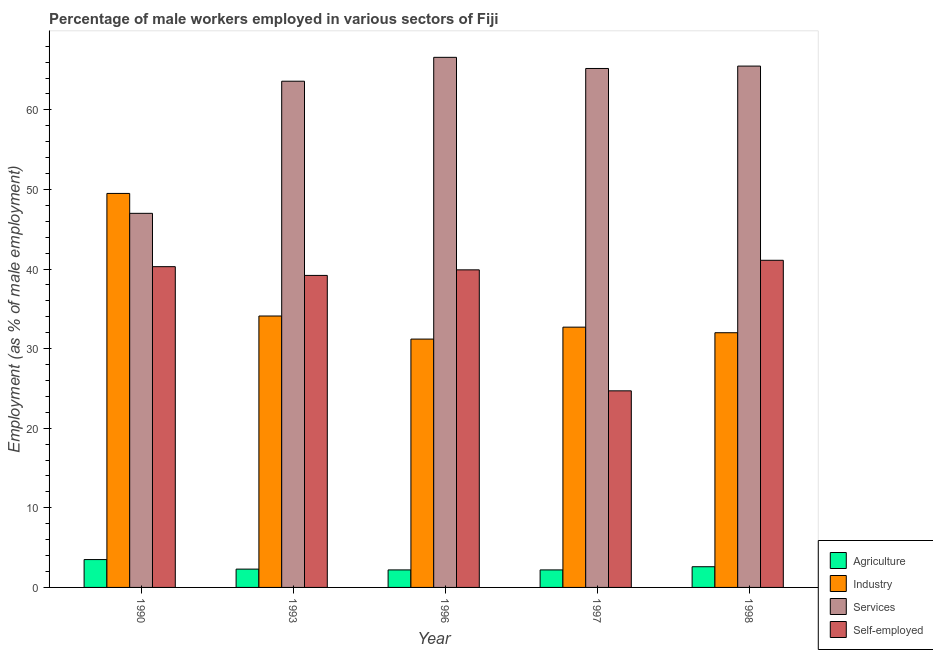Are the number of bars on each tick of the X-axis equal?
Your answer should be compact. Yes. How many bars are there on the 4th tick from the right?
Provide a short and direct response. 4. What is the label of the 5th group of bars from the left?
Your answer should be very brief. 1998. In how many cases, is the number of bars for a given year not equal to the number of legend labels?
Your response must be concise. 0. What is the percentage of male workers in industry in 1998?
Provide a short and direct response. 32. Across all years, what is the maximum percentage of male workers in services?
Make the answer very short. 66.6. Across all years, what is the minimum percentage of self employed male workers?
Your answer should be compact. 24.7. In which year was the percentage of self employed male workers maximum?
Make the answer very short. 1998. In which year was the percentage of male workers in services minimum?
Ensure brevity in your answer.  1990. What is the total percentage of male workers in services in the graph?
Your response must be concise. 307.9. What is the difference between the percentage of male workers in agriculture in 1993 and that in 1996?
Keep it short and to the point. 0.1. What is the difference between the percentage of self employed male workers in 1997 and the percentage of male workers in industry in 1990?
Provide a succinct answer. -15.6. What is the average percentage of male workers in services per year?
Give a very brief answer. 61.58. In the year 1997, what is the difference between the percentage of male workers in industry and percentage of male workers in agriculture?
Offer a terse response. 0. What is the ratio of the percentage of male workers in services in 1997 to that in 1998?
Your answer should be compact. 1. Is the difference between the percentage of male workers in industry in 1990 and 1998 greater than the difference between the percentage of male workers in services in 1990 and 1998?
Provide a succinct answer. No. What is the difference between the highest and the second highest percentage of self employed male workers?
Give a very brief answer. 0.8. What is the difference between the highest and the lowest percentage of male workers in agriculture?
Ensure brevity in your answer.  1.3. Is the sum of the percentage of male workers in agriculture in 1990 and 1997 greater than the maximum percentage of male workers in services across all years?
Provide a succinct answer. Yes. Is it the case that in every year, the sum of the percentage of male workers in agriculture and percentage of self employed male workers is greater than the sum of percentage of male workers in services and percentage of male workers in industry?
Keep it short and to the point. No. What does the 1st bar from the left in 1998 represents?
Give a very brief answer. Agriculture. What does the 3rd bar from the right in 1993 represents?
Offer a very short reply. Industry. Is it the case that in every year, the sum of the percentage of male workers in agriculture and percentage of male workers in industry is greater than the percentage of male workers in services?
Your answer should be very brief. No. How many bars are there?
Ensure brevity in your answer.  20. Are all the bars in the graph horizontal?
Your answer should be compact. No. Does the graph contain any zero values?
Offer a very short reply. No. Does the graph contain grids?
Offer a terse response. No. How many legend labels are there?
Offer a very short reply. 4. How are the legend labels stacked?
Keep it short and to the point. Vertical. What is the title of the graph?
Offer a very short reply. Percentage of male workers employed in various sectors of Fiji. What is the label or title of the Y-axis?
Offer a terse response. Employment (as % of male employment). What is the Employment (as % of male employment) of Agriculture in 1990?
Your answer should be compact. 3.5. What is the Employment (as % of male employment) of Industry in 1990?
Your answer should be very brief. 49.5. What is the Employment (as % of male employment) in Services in 1990?
Your answer should be compact. 47. What is the Employment (as % of male employment) of Self-employed in 1990?
Keep it short and to the point. 40.3. What is the Employment (as % of male employment) in Agriculture in 1993?
Offer a terse response. 2.3. What is the Employment (as % of male employment) in Industry in 1993?
Keep it short and to the point. 34.1. What is the Employment (as % of male employment) in Services in 1993?
Your answer should be very brief. 63.6. What is the Employment (as % of male employment) in Self-employed in 1993?
Offer a very short reply. 39.2. What is the Employment (as % of male employment) in Agriculture in 1996?
Provide a short and direct response. 2.2. What is the Employment (as % of male employment) in Industry in 1996?
Make the answer very short. 31.2. What is the Employment (as % of male employment) of Services in 1996?
Your answer should be compact. 66.6. What is the Employment (as % of male employment) of Self-employed in 1996?
Give a very brief answer. 39.9. What is the Employment (as % of male employment) of Agriculture in 1997?
Your answer should be compact. 2.2. What is the Employment (as % of male employment) of Industry in 1997?
Your answer should be very brief. 32.7. What is the Employment (as % of male employment) of Services in 1997?
Provide a short and direct response. 65.2. What is the Employment (as % of male employment) of Self-employed in 1997?
Make the answer very short. 24.7. What is the Employment (as % of male employment) in Agriculture in 1998?
Your answer should be compact. 2.6. What is the Employment (as % of male employment) in Industry in 1998?
Make the answer very short. 32. What is the Employment (as % of male employment) of Services in 1998?
Your answer should be compact. 65.5. What is the Employment (as % of male employment) in Self-employed in 1998?
Offer a terse response. 41.1. Across all years, what is the maximum Employment (as % of male employment) in Industry?
Provide a short and direct response. 49.5. Across all years, what is the maximum Employment (as % of male employment) of Services?
Provide a succinct answer. 66.6. Across all years, what is the maximum Employment (as % of male employment) in Self-employed?
Your response must be concise. 41.1. Across all years, what is the minimum Employment (as % of male employment) in Agriculture?
Your answer should be very brief. 2.2. Across all years, what is the minimum Employment (as % of male employment) in Industry?
Your response must be concise. 31.2. Across all years, what is the minimum Employment (as % of male employment) in Services?
Keep it short and to the point. 47. Across all years, what is the minimum Employment (as % of male employment) of Self-employed?
Give a very brief answer. 24.7. What is the total Employment (as % of male employment) of Agriculture in the graph?
Your response must be concise. 12.8. What is the total Employment (as % of male employment) of Industry in the graph?
Your response must be concise. 179.5. What is the total Employment (as % of male employment) of Services in the graph?
Keep it short and to the point. 307.9. What is the total Employment (as % of male employment) of Self-employed in the graph?
Keep it short and to the point. 185.2. What is the difference between the Employment (as % of male employment) in Industry in 1990 and that in 1993?
Give a very brief answer. 15.4. What is the difference between the Employment (as % of male employment) of Services in 1990 and that in 1993?
Provide a short and direct response. -16.6. What is the difference between the Employment (as % of male employment) in Self-employed in 1990 and that in 1993?
Your answer should be very brief. 1.1. What is the difference between the Employment (as % of male employment) of Agriculture in 1990 and that in 1996?
Offer a terse response. 1.3. What is the difference between the Employment (as % of male employment) in Services in 1990 and that in 1996?
Your answer should be compact. -19.6. What is the difference between the Employment (as % of male employment) of Industry in 1990 and that in 1997?
Keep it short and to the point. 16.8. What is the difference between the Employment (as % of male employment) in Services in 1990 and that in 1997?
Ensure brevity in your answer.  -18.2. What is the difference between the Employment (as % of male employment) in Industry in 1990 and that in 1998?
Offer a very short reply. 17.5. What is the difference between the Employment (as % of male employment) in Services in 1990 and that in 1998?
Provide a succinct answer. -18.5. What is the difference between the Employment (as % of male employment) in Agriculture in 1993 and that in 1996?
Make the answer very short. 0.1. What is the difference between the Employment (as % of male employment) of Services in 1993 and that in 1996?
Offer a terse response. -3. What is the difference between the Employment (as % of male employment) in Agriculture in 1993 and that in 1997?
Give a very brief answer. 0.1. What is the difference between the Employment (as % of male employment) in Services in 1993 and that in 1997?
Your answer should be very brief. -1.6. What is the difference between the Employment (as % of male employment) in Agriculture in 1993 and that in 1998?
Make the answer very short. -0.3. What is the difference between the Employment (as % of male employment) of Industry in 1993 and that in 1998?
Offer a terse response. 2.1. What is the difference between the Employment (as % of male employment) in Agriculture in 1996 and that in 1997?
Give a very brief answer. 0. What is the difference between the Employment (as % of male employment) in Industry in 1996 and that in 1997?
Provide a short and direct response. -1.5. What is the difference between the Employment (as % of male employment) of Agriculture in 1996 and that in 1998?
Keep it short and to the point. -0.4. What is the difference between the Employment (as % of male employment) in Services in 1996 and that in 1998?
Your answer should be compact. 1.1. What is the difference between the Employment (as % of male employment) in Self-employed in 1996 and that in 1998?
Give a very brief answer. -1.2. What is the difference between the Employment (as % of male employment) of Agriculture in 1997 and that in 1998?
Provide a short and direct response. -0.4. What is the difference between the Employment (as % of male employment) in Services in 1997 and that in 1998?
Ensure brevity in your answer.  -0.3. What is the difference between the Employment (as % of male employment) of Self-employed in 1997 and that in 1998?
Your answer should be very brief. -16.4. What is the difference between the Employment (as % of male employment) of Agriculture in 1990 and the Employment (as % of male employment) of Industry in 1993?
Make the answer very short. -30.6. What is the difference between the Employment (as % of male employment) of Agriculture in 1990 and the Employment (as % of male employment) of Services in 1993?
Provide a short and direct response. -60.1. What is the difference between the Employment (as % of male employment) of Agriculture in 1990 and the Employment (as % of male employment) of Self-employed in 1993?
Your answer should be very brief. -35.7. What is the difference between the Employment (as % of male employment) of Industry in 1990 and the Employment (as % of male employment) of Services in 1993?
Provide a succinct answer. -14.1. What is the difference between the Employment (as % of male employment) in Services in 1990 and the Employment (as % of male employment) in Self-employed in 1993?
Ensure brevity in your answer.  7.8. What is the difference between the Employment (as % of male employment) of Agriculture in 1990 and the Employment (as % of male employment) of Industry in 1996?
Ensure brevity in your answer.  -27.7. What is the difference between the Employment (as % of male employment) of Agriculture in 1990 and the Employment (as % of male employment) of Services in 1996?
Give a very brief answer. -63.1. What is the difference between the Employment (as % of male employment) in Agriculture in 1990 and the Employment (as % of male employment) in Self-employed in 1996?
Your answer should be compact. -36.4. What is the difference between the Employment (as % of male employment) in Industry in 1990 and the Employment (as % of male employment) in Services in 1996?
Keep it short and to the point. -17.1. What is the difference between the Employment (as % of male employment) in Industry in 1990 and the Employment (as % of male employment) in Self-employed in 1996?
Provide a succinct answer. 9.6. What is the difference between the Employment (as % of male employment) of Agriculture in 1990 and the Employment (as % of male employment) of Industry in 1997?
Ensure brevity in your answer.  -29.2. What is the difference between the Employment (as % of male employment) of Agriculture in 1990 and the Employment (as % of male employment) of Services in 1997?
Ensure brevity in your answer.  -61.7. What is the difference between the Employment (as % of male employment) of Agriculture in 1990 and the Employment (as % of male employment) of Self-employed in 1997?
Your answer should be compact. -21.2. What is the difference between the Employment (as % of male employment) of Industry in 1990 and the Employment (as % of male employment) of Services in 1997?
Ensure brevity in your answer.  -15.7. What is the difference between the Employment (as % of male employment) in Industry in 1990 and the Employment (as % of male employment) in Self-employed in 1997?
Ensure brevity in your answer.  24.8. What is the difference between the Employment (as % of male employment) in Services in 1990 and the Employment (as % of male employment) in Self-employed in 1997?
Provide a succinct answer. 22.3. What is the difference between the Employment (as % of male employment) of Agriculture in 1990 and the Employment (as % of male employment) of Industry in 1998?
Keep it short and to the point. -28.5. What is the difference between the Employment (as % of male employment) in Agriculture in 1990 and the Employment (as % of male employment) in Services in 1998?
Your answer should be compact. -62. What is the difference between the Employment (as % of male employment) in Agriculture in 1990 and the Employment (as % of male employment) in Self-employed in 1998?
Your response must be concise. -37.6. What is the difference between the Employment (as % of male employment) in Industry in 1990 and the Employment (as % of male employment) in Self-employed in 1998?
Offer a very short reply. 8.4. What is the difference between the Employment (as % of male employment) in Services in 1990 and the Employment (as % of male employment) in Self-employed in 1998?
Give a very brief answer. 5.9. What is the difference between the Employment (as % of male employment) in Agriculture in 1993 and the Employment (as % of male employment) in Industry in 1996?
Your response must be concise. -28.9. What is the difference between the Employment (as % of male employment) in Agriculture in 1993 and the Employment (as % of male employment) in Services in 1996?
Your answer should be very brief. -64.3. What is the difference between the Employment (as % of male employment) in Agriculture in 1993 and the Employment (as % of male employment) in Self-employed in 1996?
Provide a succinct answer. -37.6. What is the difference between the Employment (as % of male employment) in Industry in 1993 and the Employment (as % of male employment) in Services in 1996?
Make the answer very short. -32.5. What is the difference between the Employment (as % of male employment) in Industry in 1993 and the Employment (as % of male employment) in Self-employed in 1996?
Make the answer very short. -5.8. What is the difference between the Employment (as % of male employment) in Services in 1993 and the Employment (as % of male employment) in Self-employed in 1996?
Provide a succinct answer. 23.7. What is the difference between the Employment (as % of male employment) in Agriculture in 1993 and the Employment (as % of male employment) in Industry in 1997?
Keep it short and to the point. -30.4. What is the difference between the Employment (as % of male employment) in Agriculture in 1993 and the Employment (as % of male employment) in Services in 1997?
Your response must be concise. -62.9. What is the difference between the Employment (as % of male employment) in Agriculture in 1993 and the Employment (as % of male employment) in Self-employed in 1997?
Your response must be concise. -22.4. What is the difference between the Employment (as % of male employment) of Industry in 1993 and the Employment (as % of male employment) of Services in 1997?
Offer a terse response. -31.1. What is the difference between the Employment (as % of male employment) of Services in 1993 and the Employment (as % of male employment) of Self-employed in 1997?
Give a very brief answer. 38.9. What is the difference between the Employment (as % of male employment) of Agriculture in 1993 and the Employment (as % of male employment) of Industry in 1998?
Offer a very short reply. -29.7. What is the difference between the Employment (as % of male employment) of Agriculture in 1993 and the Employment (as % of male employment) of Services in 1998?
Make the answer very short. -63.2. What is the difference between the Employment (as % of male employment) in Agriculture in 1993 and the Employment (as % of male employment) in Self-employed in 1998?
Make the answer very short. -38.8. What is the difference between the Employment (as % of male employment) of Industry in 1993 and the Employment (as % of male employment) of Services in 1998?
Offer a very short reply. -31.4. What is the difference between the Employment (as % of male employment) in Agriculture in 1996 and the Employment (as % of male employment) in Industry in 1997?
Provide a short and direct response. -30.5. What is the difference between the Employment (as % of male employment) in Agriculture in 1996 and the Employment (as % of male employment) in Services in 1997?
Your answer should be compact. -63. What is the difference between the Employment (as % of male employment) in Agriculture in 1996 and the Employment (as % of male employment) in Self-employed in 1997?
Your answer should be compact. -22.5. What is the difference between the Employment (as % of male employment) of Industry in 1996 and the Employment (as % of male employment) of Services in 1997?
Your answer should be very brief. -34. What is the difference between the Employment (as % of male employment) of Industry in 1996 and the Employment (as % of male employment) of Self-employed in 1997?
Your answer should be compact. 6.5. What is the difference between the Employment (as % of male employment) in Services in 1996 and the Employment (as % of male employment) in Self-employed in 1997?
Provide a short and direct response. 41.9. What is the difference between the Employment (as % of male employment) of Agriculture in 1996 and the Employment (as % of male employment) of Industry in 1998?
Offer a very short reply. -29.8. What is the difference between the Employment (as % of male employment) of Agriculture in 1996 and the Employment (as % of male employment) of Services in 1998?
Make the answer very short. -63.3. What is the difference between the Employment (as % of male employment) of Agriculture in 1996 and the Employment (as % of male employment) of Self-employed in 1998?
Offer a terse response. -38.9. What is the difference between the Employment (as % of male employment) in Industry in 1996 and the Employment (as % of male employment) in Services in 1998?
Your answer should be very brief. -34.3. What is the difference between the Employment (as % of male employment) in Services in 1996 and the Employment (as % of male employment) in Self-employed in 1998?
Provide a succinct answer. 25.5. What is the difference between the Employment (as % of male employment) in Agriculture in 1997 and the Employment (as % of male employment) in Industry in 1998?
Your response must be concise. -29.8. What is the difference between the Employment (as % of male employment) of Agriculture in 1997 and the Employment (as % of male employment) of Services in 1998?
Make the answer very short. -63.3. What is the difference between the Employment (as % of male employment) in Agriculture in 1997 and the Employment (as % of male employment) in Self-employed in 1998?
Give a very brief answer. -38.9. What is the difference between the Employment (as % of male employment) in Industry in 1997 and the Employment (as % of male employment) in Services in 1998?
Make the answer very short. -32.8. What is the difference between the Employment (as % of male employment) of Industry in 1997 and the Employment (as % of male employment) of Self-employed in 1998?
Your answer should be very brief. -8.4. What is the difference between the Employment (as % of male employment) of Services in 1997 and the Employment (as % of male employment) of Self-employed in 1998?
Your response must be concise. 24.1. What is the average Employment (as % of male employment) of Agriculture per year?
Offer a very short reply. 2.56. What is the average Employment (as % of male employment) of Industry per year?
Your answer should be compact. 35.9. What is the average Employment (as % of male employment) of Services per year?
Offer a terse response. 61.58. What is the average Employment (as % of male employment) in Self-employed per year?
Offer a terse response. 37.04. In the year 1990, what is the difference between the Employment (as % of male employment) in Agriculture and Employment (as % of male employment) in Industry?
Offer a very short reply. -46. In the year 1990, what is the difference between the Employment (as % of male employment) of Agriculture and Employment (as % of male employment) of Services?
Keep it short and to the point. -43.5. In the year 1990, what is the difference between the Employment (as % of male employment) in Agriculture and Employment (as % of male employment) in Self-employed?
Your answer should be very brief. -36.8. In the year 1990, what is the difference between the Employment (as % of male employment) in Industry and Employment (as % of male employment) in Services?
Your answer should be compact. 2.5. In the year 1993, what is the difference between the Employment (as % of male employment) of Agriculture and Employment (as % of male employment) of Industry?
Provide a succinct answer. -31.8. In the year 1993, what is the difference between the Employment (as % of male employment) of Agriculture and Employment (as % of male employment) of Services?
Keep it short and to the point. -61.3. In the year 1993, what is the difference between the Employment (as % of male employment) in Agriculture and Employment (as % of male employment) in Self-employed?
Your answer should be compact. -36.9. In the year 1993, what is the difference between the Employment (as % of male employment) of Industry and Employment (as % of male employment) of Services?
Your answer should be very brief. -29.5. In the year 1993, what is the difference between the Employment (as % of male employment) in Industry and Employment (as % of male employment) in Self-employed?
Your answer should be very brief. -5.1. In the year 1993, what is the difference between the Employment (as % of male employment) of Services and Employment (as % of male employment) of Self-employed?
Your answer should be compact. 24.4. In the year 1996, what is the difference between the Employment (as % of male employment) in Agriculture and Employment (as % of male employment) in Services?
Your response must be concise. -64.4. In the year 1996, what is the difference between the Employment (as % of male employment) of Agriculture and Employment (as % of male employment) of Self-employed?
Offer a very short reply. -37.7. In the year 1996, what is the difference between the Employment (as % of male employment) of Industry and Employment (as % of male employment) of Services?
Make the answer very short. -35.4. In the year 1996, what is the difference between the Employment (as % of male employment) of Industry and Employment (as % of male employment) of Self-employed?
Offer a very short reply. -8.7. In the year 1996, what is the difference between the Employment (as % of male employment) in Services and Employment (as % of male employment) in Self-employed?
Provide a short and direct response. 26.7. In the year 1997, what is the difference between the Employment (as % of male employment) of Agriculture and Employment (as % of male employment) of Industry?
Give a very brief answer. -30.5. In the year 1997, what is the difference between the Employment (as % of male employment) of Agriculture and Employment (as % of male employment) of Services?
Your response must be concise. -63. In the year 1997, what is the difference between the Employment (as % of male employment) in Agriculture and Employment (as % of male employment) in Self-employed?
Provide a succinct answer. -22.5. In the year 1997, what is the difference between the Employment (as % of male employment) in Industry and Employment (as % of male employment) in Services?
Keep it short and to the point. -32.5. In the year 1997, what is the difference between the Employment (as % of male employment) of Industry and Employment (as % of male employment) of Self-employed?
Make the answer very short. 8. In the year 1997, what is the difference between the Employment (as % of male employment) of Services and Employment (as % of male employment) of Self-employed?
Keep it short and to the point. 40.5. In the year 1998, what is the difference between the Employment (as % of male employment) in Agriculture and Employment (as % of male employment) in Industry?
Provide a short and direct response. -29.4. In the year 1998, what is the difference between the Employment (as % of male employment) of Agriculture and Employment (as % of male employment) of Services?
Offer a very short reply. -62.9. In the year 1998, what is the difference between the Employment (as % of male employment) of Agriculture and Employment (as % of male employment) of Self-employed?
Give a very brief answer. -38.5. In the year 1998, what is the difference between the Employment (as % of male employment) in Industry and Employment (as % of male employment) in Services?
Offer a terse response. -33.5. In the year 1998, what is the difference between the Employment (as % of male employment) in Services and Employment (as % of male employment) in Self-employed?
Your answer should be very brief. 24.4. What is the ratio of the Employment (as % of male employment) of Agriculture in 1990 to that in 1993?
Ensure brevity in your answer.  1.52. What is the ratio of the Employment (as % of male employment) of Industry in 1990 to that in 1993?
Keep it short and to the point. 1.45. What is the ratio of the Employment (as % of male employment) of Services in 1990 to that in 1993?
Provide a short and direct response. 0.74. What is the ratio of the Employment (as % of male employment) in Self-employed in 1990 to that in 1993?
Give a very brief answer. 1.03. What is the ratio of the Employment (as % of male employment) in Agriculture in 1990 to that in 1996?
Your response must be concise. 1.59. What is the ratio of the Employment (as % of male employment) in Industry in 1990 to that in 1996?
Keep it short and to the point. 1.59. What is the ratio of the Employment (as % of male employment) in Services in 1990 to that in 1996?
Ensure brevity in your answer.  0.71. What is the ratio of the Employment (as % of male employment) of Agriculture in 1990 to that in 1997?
Keep it short and to the point. 1.59. What is the ratio of the Employment (as % of male employment) of Industry in 1990 to that in 1997?
Make the answer very short. 1.51. What is the ratio of the Employment (as % of male employment) of Services in 1990 to that in 1997?
Provide a short and direct response. 0.72. What is the ratio of the Employment (as % of male employment) in Self-employed in 1990 to that in 1997?
Offer a very short reply. 1.63. What is the ratio of the Employment (as % of male employment) in Agriculture in 1990 to that in 1998?
Ensure brevity in your answer.  1.35. What is the ratio of the Employment (as % of male employment) of Industry in 1990 to that in 1998?
Ensure brevity in your answer.  1.55. What is the ratio of the Employment (as % of male employment) of Services in 1990 to that in 1998?
Give a very brief answer. 0.72. What is the ratio of the Employment (as % of male employment) in Self-employed in 1990 to that in 1998?
Offer a terse response. 0.98. What is the ratio of the Employment (as % of male employment) of Agriculture in 1993 to that in 1996?
Your response must be concise. 1.05. What is the ratio of the Employment (as % of male employment) of Industry in 1993 to that in 1996?
Offer a terse response. 1.09. What is the ratio of the Employment (as % of male employment) in Services in 1993 to that in 1996?
Ensure brevity in your answer.  0.95. What is the ratio of the Employment (as % of male employment) in Self-employed in 1993 to that in 1996?
Provide a short and direct response. 0.98. What is the ratio of the Employment (as % of male employment) of Agriculture in 1993 to that in 1997?
Ensure brevity in your answer.  1.05. What is the ratio of the Employment (as % of male employment) of Industry in 1993 to that in 1997?
Your response must be concise. 1.04. What is the ratio of the Employment (as % of male employment) of Services in 1993 to that in 1997?
Give a very brief answer. 0.98. What is the ratio of the Employment (as % of male employment) of Self-employed in 1993 to that in 1997?
Ensure brevity in your answer.  1.59. What is the ratio of the Employment (as % of male employment) in Agriculture in 1993 to that in 1998?
Give a very brief answer. 0.88. What is the ratio of the Employment (as % of male employment) of Industry in 1993 to that in 1998?
Offer a very short reply. 1.07. What is the ratio of the Employment (as % of male employment) in Self-employed in 1993 to that in 1998?
Provide a succinct answer. 0.95. What is the ratio of the Employment (as % of male employment) of Agriculture in 1996 to that in 1997?
Make the answer very short. 1. What is the ratio of the Employment (as % of male employment) in Industry in 1996 to that in 1997?
Your answer should be compact. 0.95. What is the ratio of the Employment (as % of male employment) of Services in 1996 to that in 1997?
Ensure brevity in your answer.  1.02. What is the ratio of the Employment (as % of male employment) in Self-employed in 1996 to that in 1997?
Your answer should be very brief. 1.62. What is the ratio of the Employment (as % of male employment) of Agriculture in 1996 to that in 1998?
Make the answer very short. 0.85. What is the ratio of the Employment (as % of male employment) in Services in 1996 to that in 1998?
Keep it short and to the point. 1.02. What is the ratio of the Employment (as % of male employment) of Self-employed in 1996 to that in 1998?
Keep it short and to the point. 0.97. What is the ratio of the Employment (as % of male employment) of Agriculture in 1997 to that in 1998?
Your answer should be compact. 0.85. What is the ratio of the Employment (as % of male employment) in Industry in 1997 to that in 1998?
Your response must be concise. 1.02. What is the ratio of the Employment (as % of male employment) in Self-employed in 1997 to that in 1998?
Provide a succinct answer. 0.6. What is the difference between the highest and the second highest Employment (as % of male employment) of Services?
Provide a succinct answer. 1.1. What is the difference between the highest and the second highest Employment (as % of male employment) in Self-employed?
Provide a short and direct response. 0.8. What is the difference between the highest and the lowest Employment (as % of male employment) in Services?
Offer a very short reply. 19.6. What is the difference between the highest and the lowest Employment (as % of male employment) of Self-employed?
Provide a succinct answer. 16.4. 